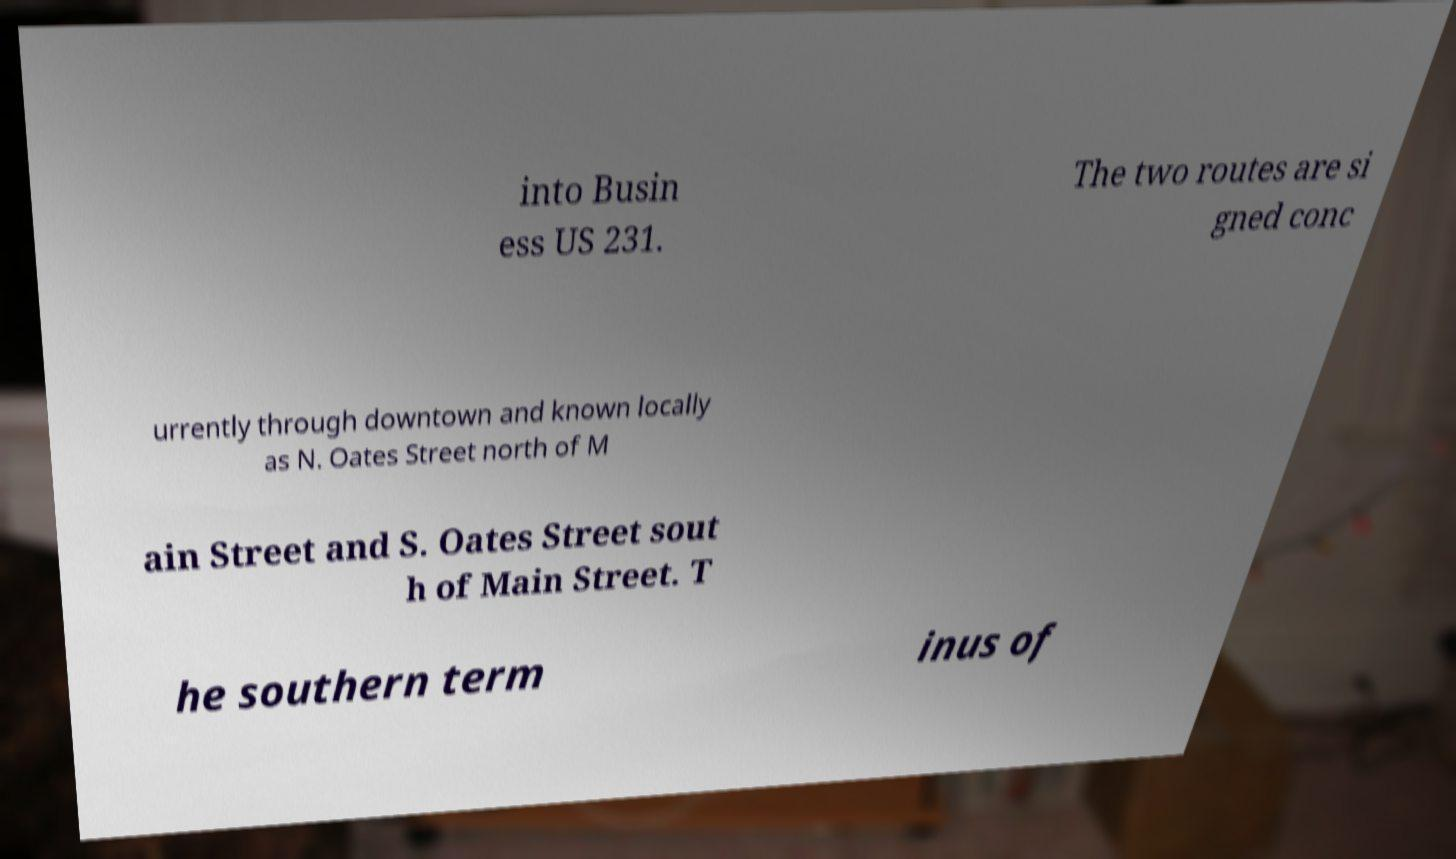Please read and relay the text visible in this image. What does it say? into Busin ess US 231. The two routes are si gned conc urrently through downtown and known locally as N. Oates Street north of M ain Street and S. Oates Street sout h of Main Street. T he southern term inus of 